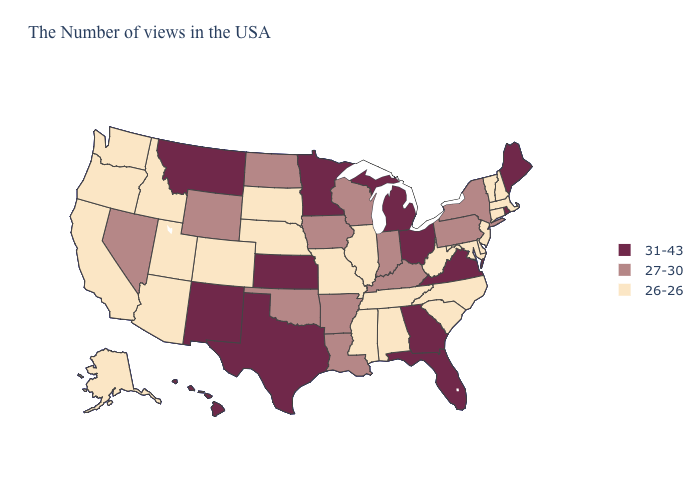Which states have the highest value in the USA?
Answer briefly. Maine, Rhode Island, Virginia, Ohio, Florida, Georgia, Michigan, Minnesota, Kansas, Texas, New Mexico, Montana, Hawaii. Name the states that have a value in the range 26-26?
Concise answer only. Massachusetts, New Hampshire, Vermont, Connecticut, New Jersey, Delaware, Maryland, North Carolina, South Carolina, West Virginia, Alabama, Tennessee, Illinois, Mississippi, Missouri, Nebraska, South Dakota, Colorado, Utah, Arizona, Idaho, California, Washington, Oregon, Alaska. What is the value of Connecticut?
Keep it brief. 26-26. Does Vermont have the lowest value in the Northeast?
Give a very brief answer. Yes. Among the states that border Louisiana , which have the highest value?
Give a very brief answer. Texas. Among the states that border Louisiana , which have the lowest value?
Be succinct. Mississippi. Name the states that have a value in the range 31-43?
Short answer required. Maine, Rhode Island, Virginia, Ohio, Florida, Georgia, Michigan, Minnesota, Kansas, Texas, New Mexico, Montana, Hawaii. Name the states that have a value in the range 26-26?
Quick response, please. Massachusetts, New Hampshire, Vermont, Connecticut, New Jersey, Delaware, Maryland, North Carolina, South Carolina, West Virginia, Alabama, Tennessee, Illinois, Mississippi, Missouri, Nebraska, South Dakota, Colorado, Utah, Arizona, Idaho, California, Washington, Oregon, Alaska. Name the states that have a value in the range 31-43?
Concise answer only. Maine, Rhode Island, Virginia, Ohio, Florida, Georgia, Michigan, Minnesota, Kansas, Texas, New Mexico, Montana, Hawaii. How many symbols are there in the legend?
Write a very short answer. 3. What is the lowest value in the USA?
Keep it brief. 26-26. What is the value of Alabama?
Be succinct. 26-26. Does the map have missing data?
Keep it brief. No. What is the value of Nevada?
Short answer required. 27-30. Among the states that border Nebraska , which have the lowest value?
Concise answer only. Missouri, South Dakota, Colorado. 